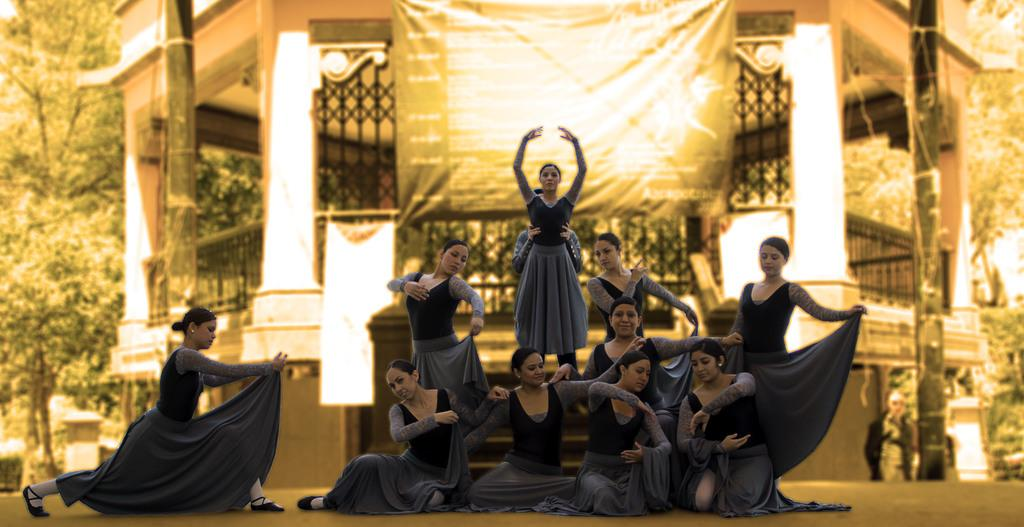What is happening in the image involving a group of people? There is a group of girls in the image, and they are performing a dance. What specific action are the girls doing in the image? The girls are giving a pose in the image. What can be seen in the background of the image? There is a building and trees in the background of the image. How many apples are being held by the girls in the image? There are no apples present in the image. What type of lock is visible on the building in the background? There is no lock visible on the building in the background; only the building itself and trees are present. 